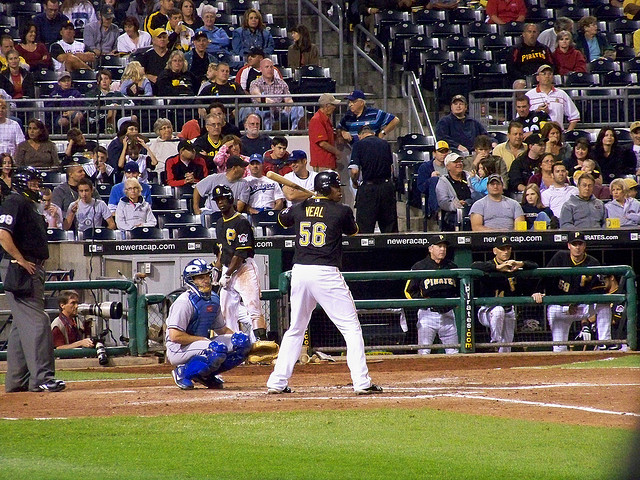Please extract the text content from this image. WAEL 56 neweracap. 38 .com nev  p  cap.com 